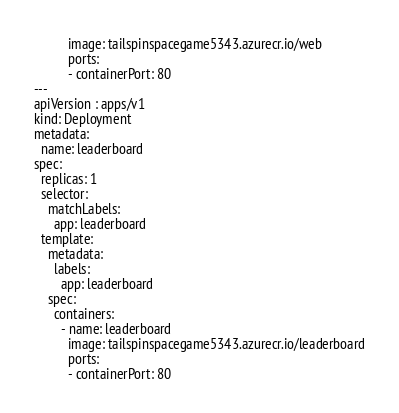Convert code to text. <code><loc_0><loc_0><loc_500><loc_500><_YAML_>          image: tailspinspacegame5343.azurecr.io/web
          ports:
          - containerPort: 80
---
apiVersion : apps/v1
kind: Deployment
metadata:
  name: leaderboard
spec:
  replicas: 1
  selector:
    matchLabels:
      app: leaderboard
  template:
    metadata:
      labels:
        app: leaderboard
    spec:
      containers:
        - name: leaderboard
          image: tailspinspacegame5343.azurecr.io/leaderboard
          ports:
          - containerPort: 80
</code> 